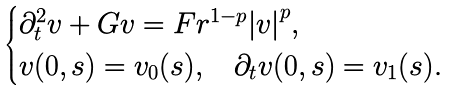Convert formula to latex. <formula><loc_0><loc_0><loc_500><loc_500>\begin{cases} \partial ^ { 2 } _ { t } v + G v = F r ^ { 1 - p } { | v | } ^ { p } , \\ v ( 0 , s ) = v _ { 0 } ( s ) , \quad \partial _ { t } v ( 0 , s ) = v _ { 1 } ( s ) . \end{cases}</formula> 